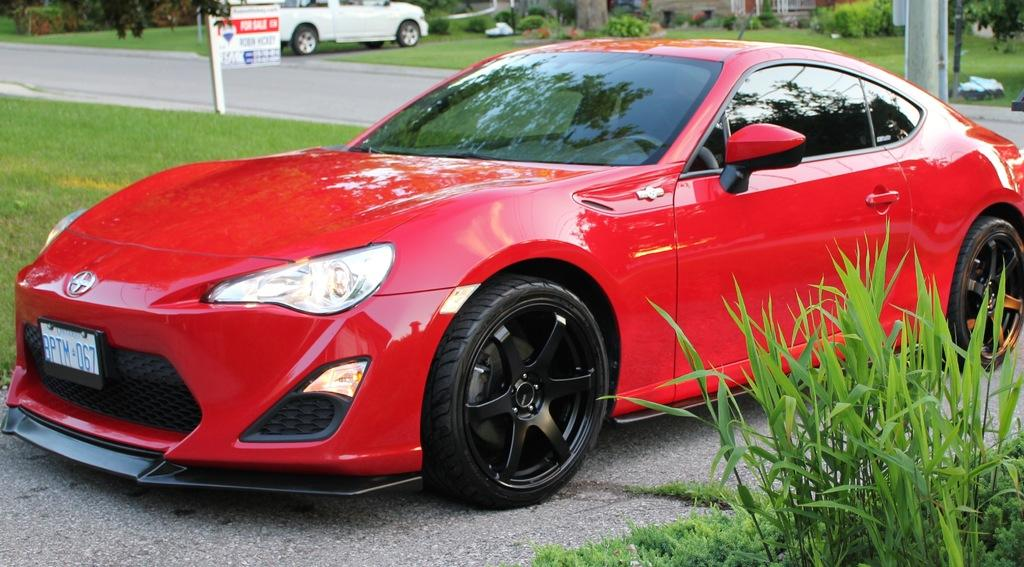What can be seen in the foreground of the picture? In the foreground of the picture, there are plants, grass, and a red color car. What is present in both the foreground and background of the picture? Both the foreground and background of the picture contain plants and grass. What can be seen in the background of the picture? In the background of the picture, there are plants, cardboard, trees, buildings, grass, and a road. What type of suit is the plantation owner wearing in the image? There is no plantation owner or suit present in the image. Can you tell me where the zipper is located on the cardboard in the image? There is no zipper present on the cardboard in the image. 